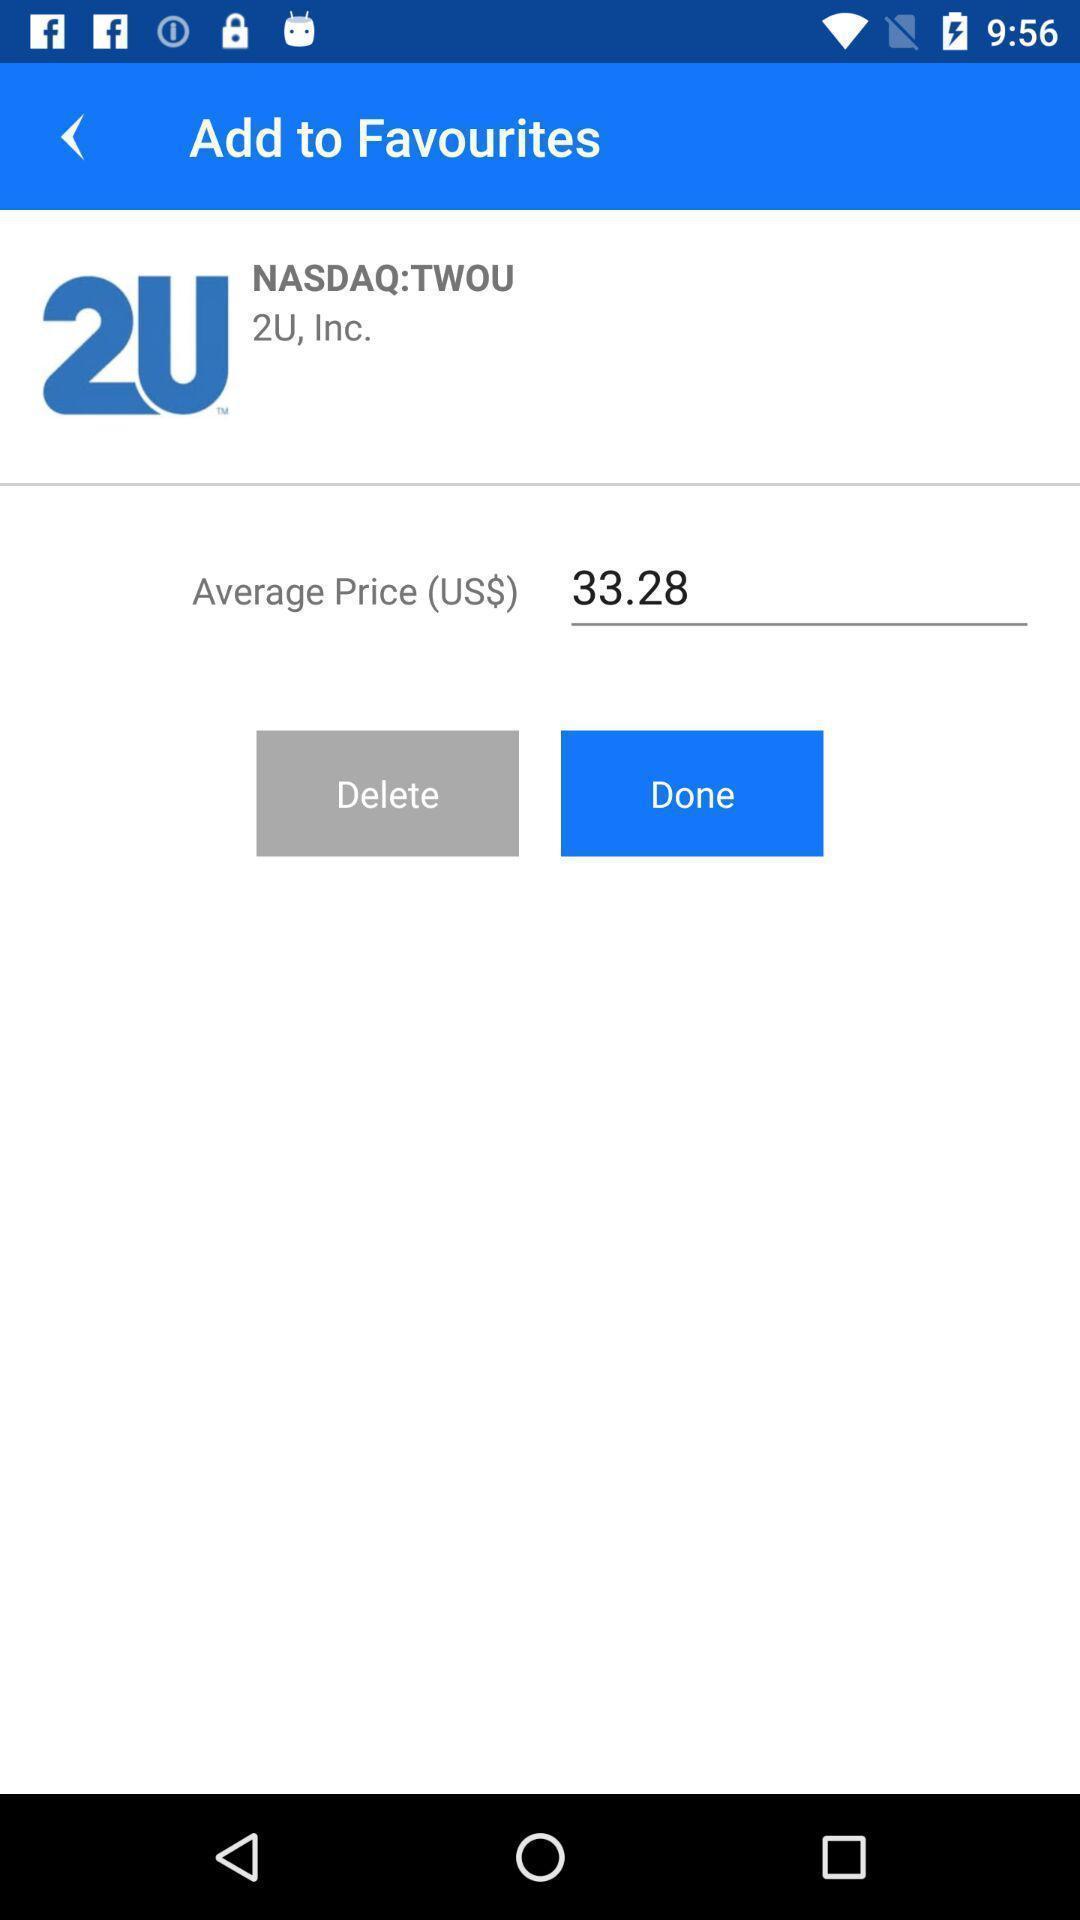Describe the content in this image. Screen shows favourites. 